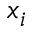<formula> <loc_0><loc_0><loc_500><loc_500>x _ { i }</formula> 